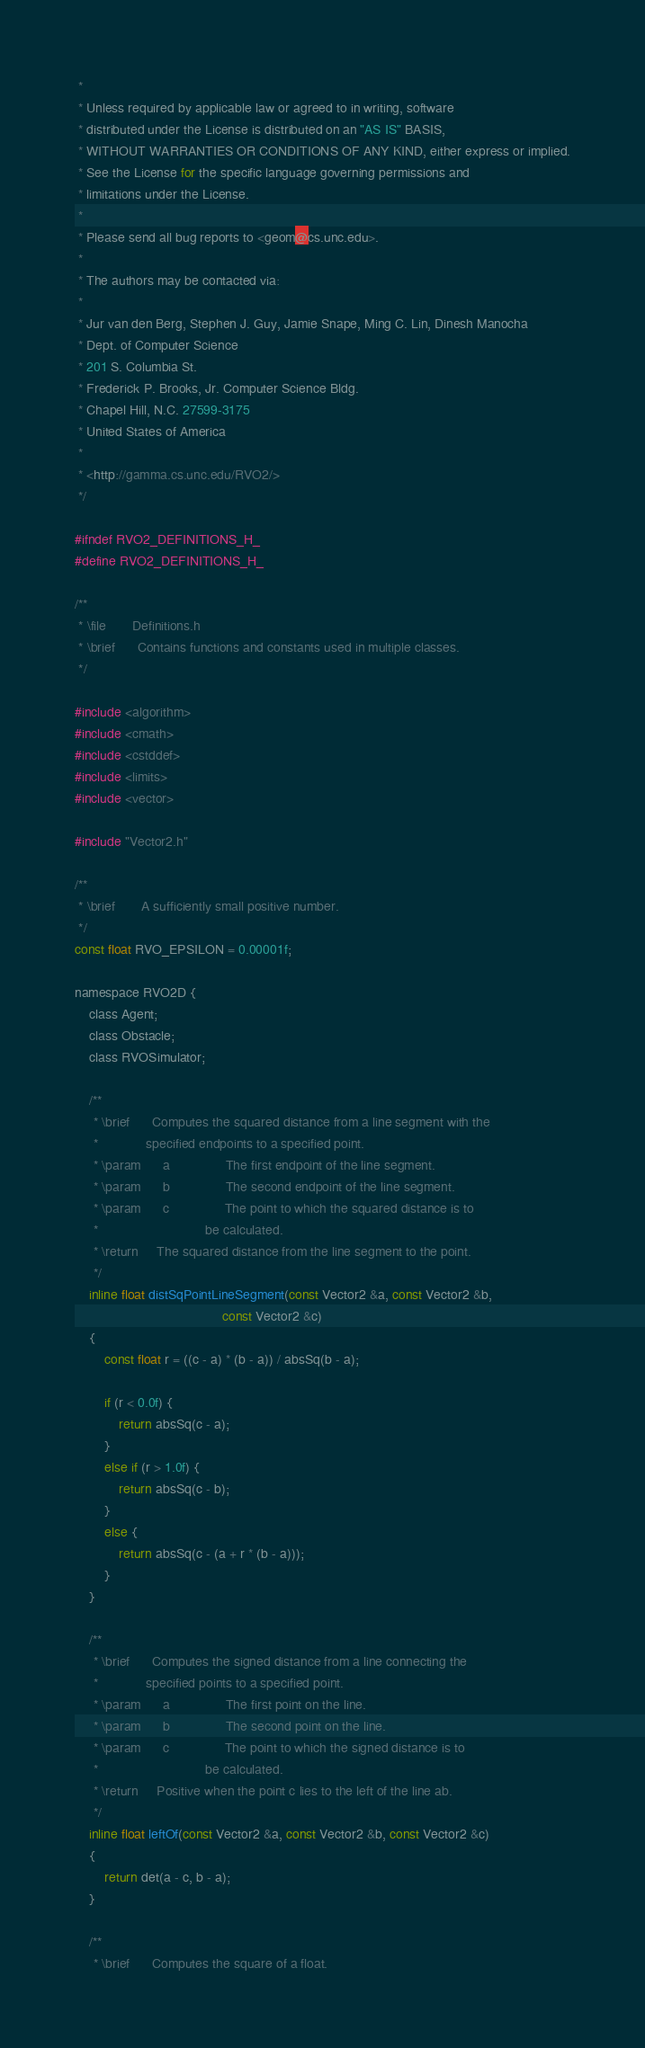Convert code to text. <code><loc_0><loc_0><loc_500><loc_500><_C_> *
 * Unless required by applicable law or agreed to in writing, software
 * distributed under the License is distributed on an "AS IS" BASIS,
 * WITHOUT WARRANTIES OR CONDITIONS OF ANY KIND, either express or implied.
 * See the License for the specific language governing permissions and
 * limitations under the License.
 *
 * Please send all bug reports to <geom@cs.unc.edu>.
 *
 * The authors may be contacted via:
 *
 * Jur van den Berg, Stephen J. Guy, Jamie Snape, Ming C. Lin, Dinesh Manocha
 * Dept. of Computer Science
 * 201 S. Columbia St.
 * Frederick P. Brooks, Jr. Computer Science Bldg.
 * Chapel Hill, N.C. 27599-3175
 * United States of America
 *
 * <http://gamma.cs.unc.edu/RVO2/>
 */

#ifndef RVO2_DEFINITIONS_H_
#define RVO2_DEFINITIONS_H_

/**
 * \file       Definitions.h
 * \brief      Contains functions and constants used in multiple classes.
 */

#include <algorithm>
#include <cmath>
#include <cstddef>
#include <limits>
#include <vector>

#include "Vector2.h"

/**
 * \brief       A sufficiently small positive number.
 */
const float RVO_EPSILON = 0.00001f;

namespace RVO2D {
	class Agent;
	class Obstacle;
	class RVOSimulator;

	/**
	 * \brief      Computes the squared distance from a line segment with the
	 *             specified endpoints to a specified point.
	 * \param      a               The first endpoint of the line segment.
	 * \param      b               The second endpoint of the line segment.
	 * \param      c               The point to which the squared distance is to
	 *                             be calculated.
	 * \return     The squared distance from the line segment to the point.
	 */
	inline float distSqPointLineSegment(const Vector2 &a, const Vector2 &b,
										const Vector2 &c)
	{
		const float r = ((c - a) * (b - a)) / absSq(b - a);

		if (r < 0.0f) {
			return absSq(c - a);
		}
		else if (r > 1.0f) {
			return absSq(c - b);
		}
		else {
			return absSq(c - (a + r * (b - a)));
		}
	}

	/**
	 * \brief      Computes the signed distance from a line connecting the
	 *             specified points to a specified point.
	 * \param      a               The first point on the line.
	 * \param      b               The second point on the line.
	 * \param      c               The point to which the signed distance is to
	 *                             be calculated.
	 * \return     Positive when the point c lies to the left of the line ab.
	 */
	inline float leftOf(const Vector2 &a, const Vector2 &b, const Vector2 &c)
	{
		return det(a - c, b - a);
	}

	/**
	 * \brief      Computes the square of a float.</code> 